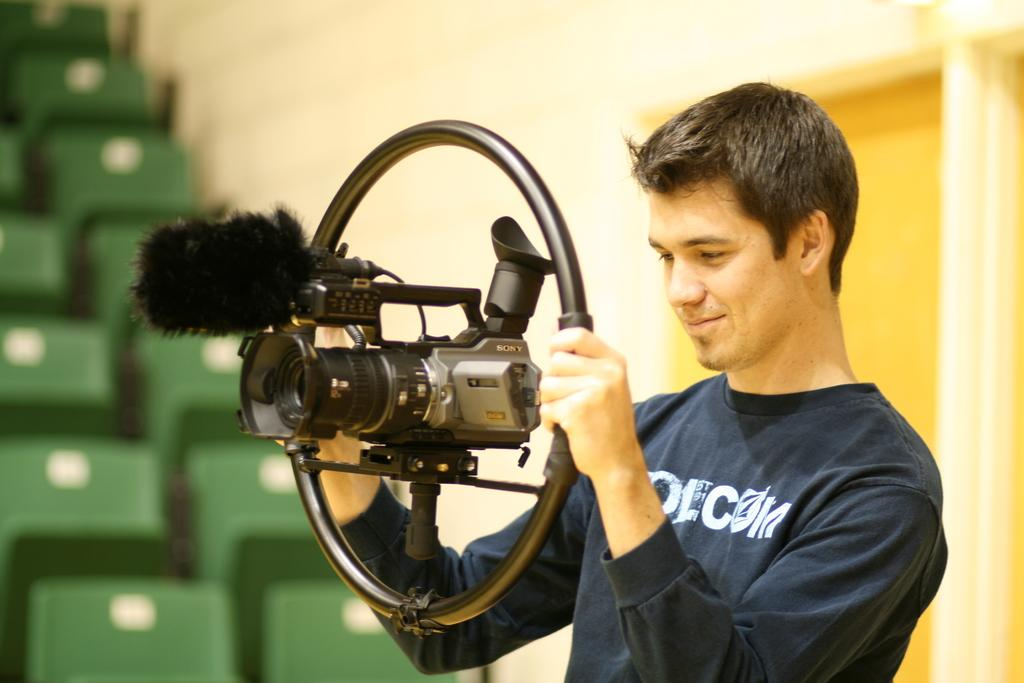Who is the main subject of focus of the image? There is a person in the center of the image. What is the person holding in the image? The person is holding a camera. What can be seen in the background of the image? There are chairs and a wall in the background of the image. What type of pest can be seen climbing on the wall in the image? There is no pest visible in the image; only a person holding a camera and chairs and a wall in the background are present. 